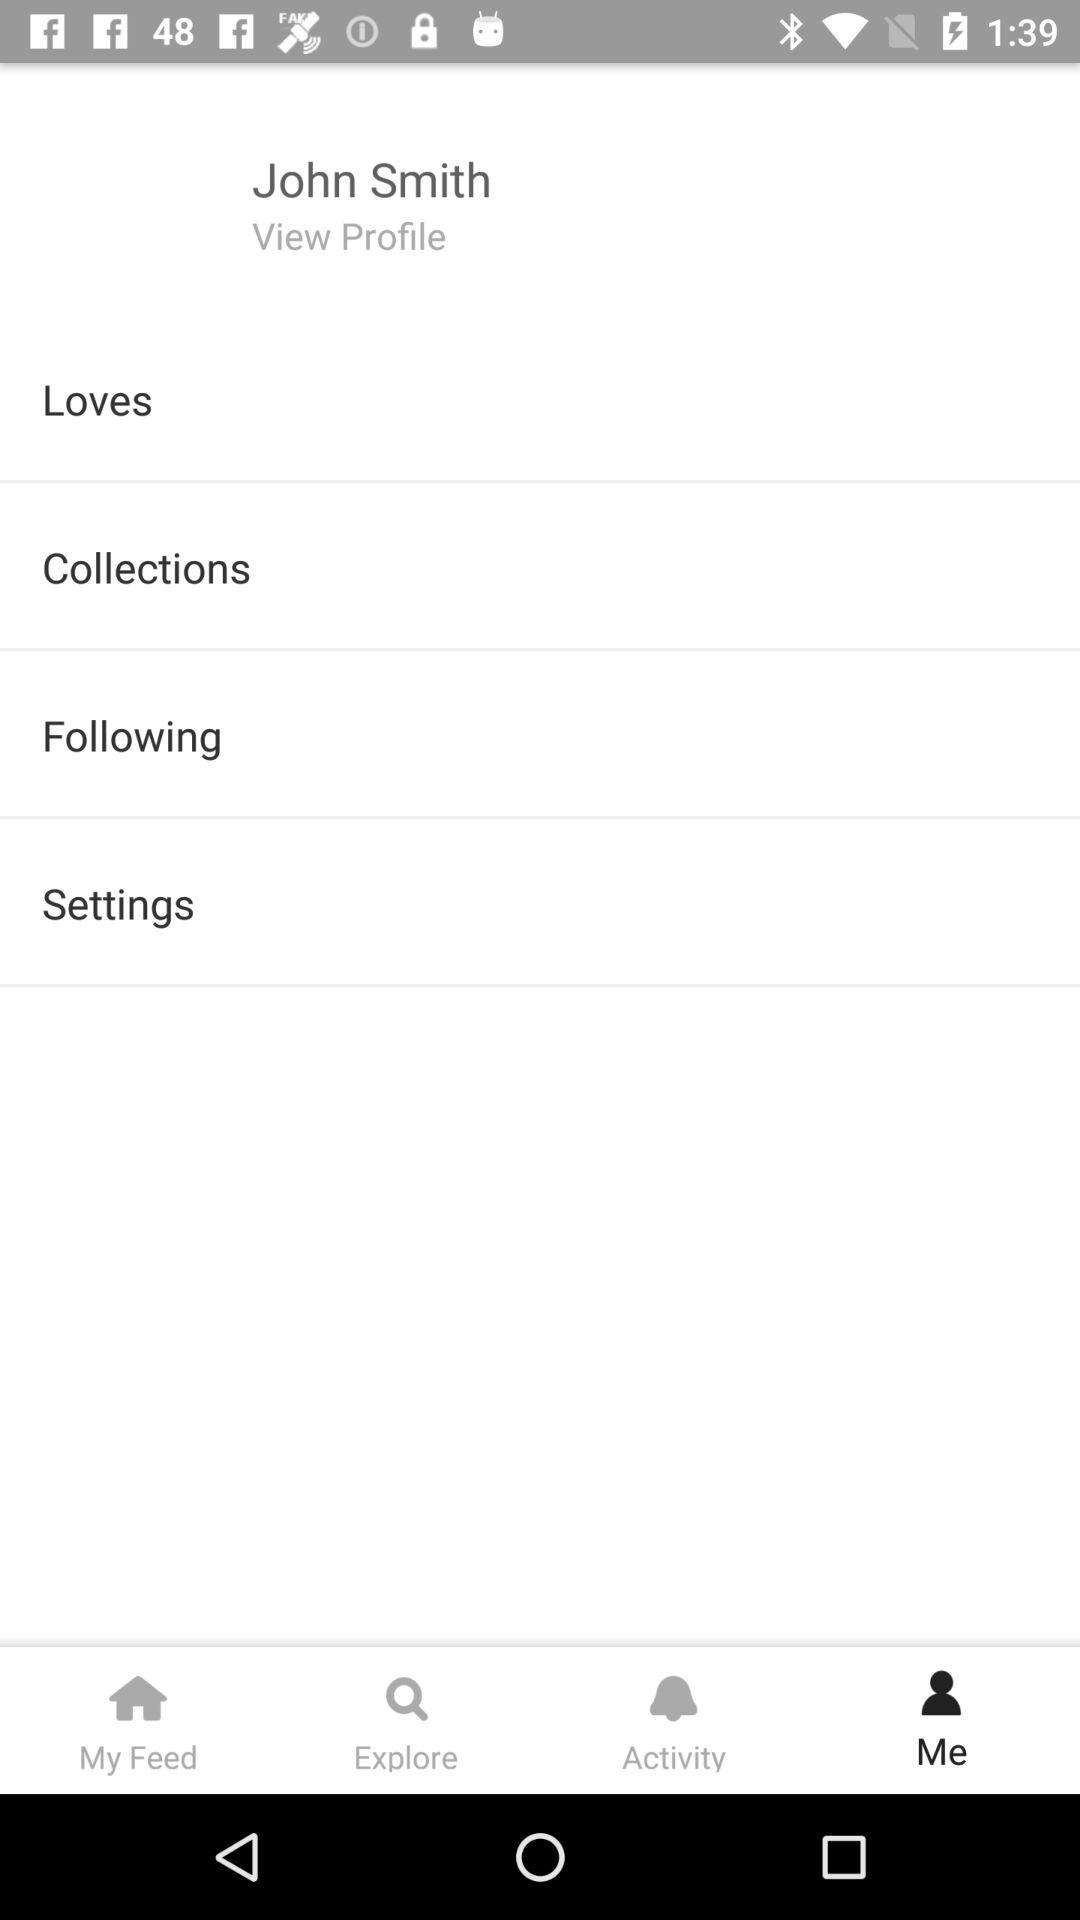What is the name of the user? The user name is John Smith. 